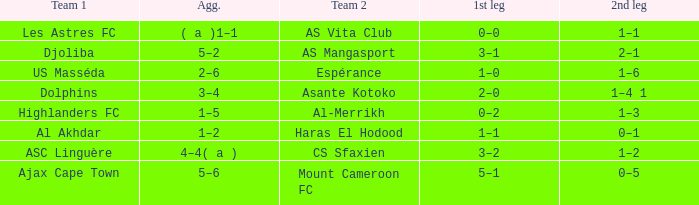What is the team 1 with team 2 Mount Cameroon FC? Ajax Cape Town. Help me parse the entirety of this table. {'header': ['Team 1', 'Agg.', 'Team 2', '1st leg', '2nd leg'], 'rows': [['Les Astres FC', '( a )1–1', 'AS Vita Club', '0–0', '1–1'], ['Djoliba', '5–2', 'AS Mangasport', '3–1', '2–1'], ['US Masséda', '2–6', 'Espérance', '1–0', '1–6'], ['Dolphins', '3–4', 'Asante Kotoko', '2–0', '1–4 1'], ['Highlanders FC', '1–5', 'Al-Merrikh', '0–2', '1–3'], ['Al Akhdar', '1–2', 'Haras El Hodood', '1–1', '0–1'], ['ASC Linguère', '4–4( a )', 'CS Sfaxien', '3–2', '1–2'], ['Ajax Cape Town', '5–6', 'Mount Cameroon FC', '5–1', '0–5']]} 